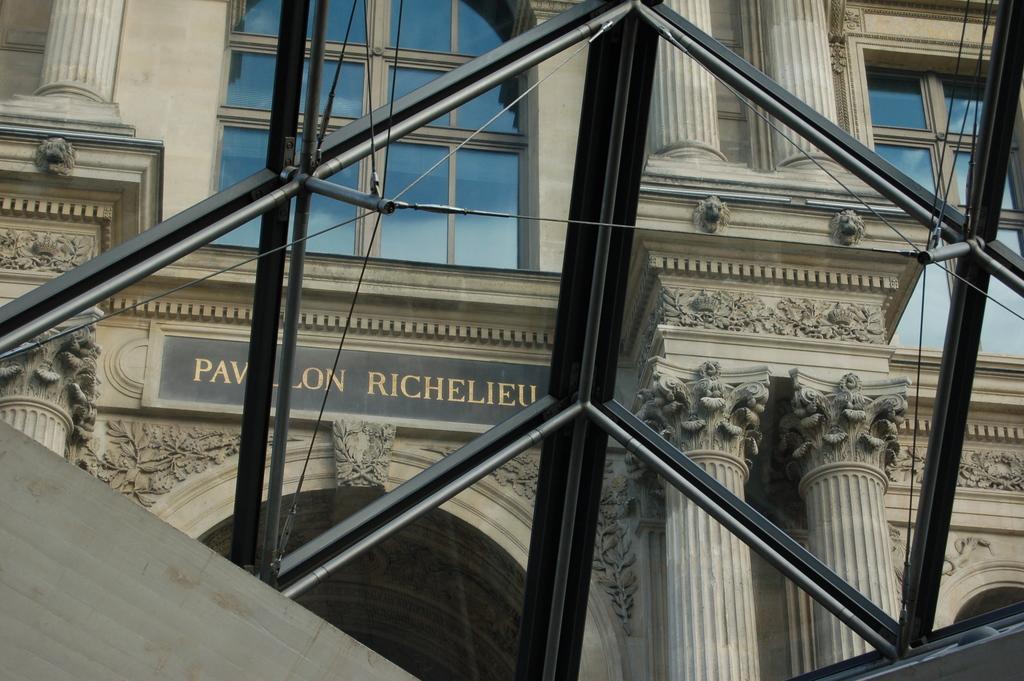Can you describe this image briefly? There is a fence. In the background, there is a building which is having glass windows and a hoarding on the wall. 